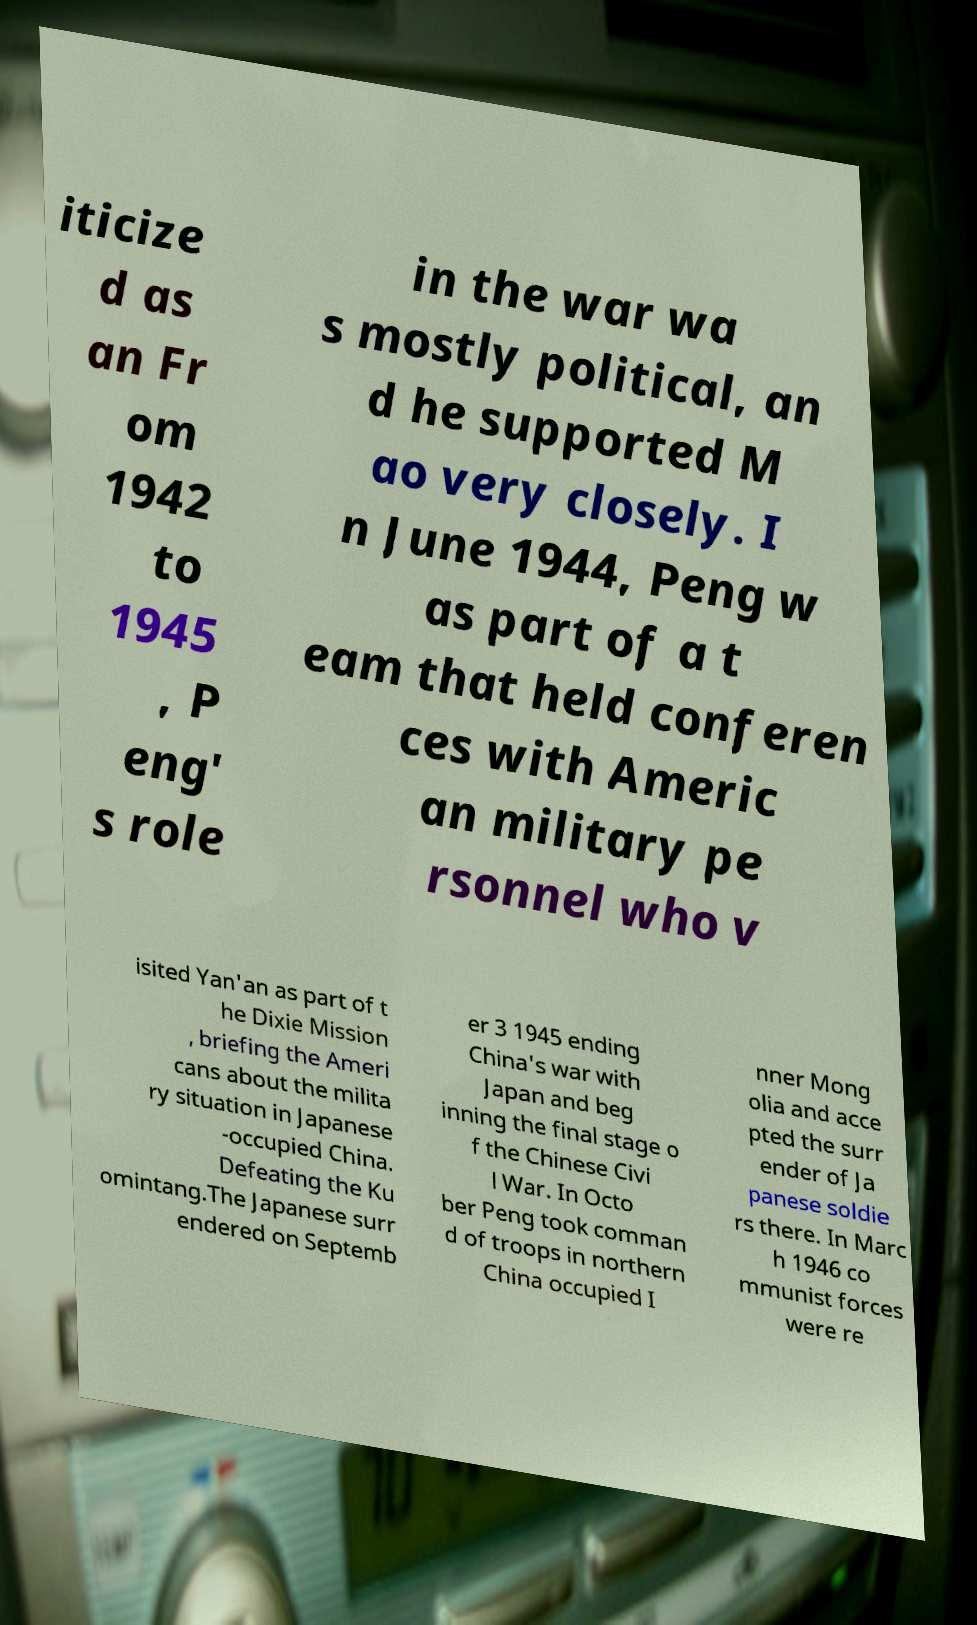I need the written content from this picture converted into text. Can you do that? iticize d as an Fr om 1942 to 1945 , P eng' s role in the war wa s mostly political, an d he supported M ao very closely. I n June 1944, Peng w as part of a t eam that held conferen ces with Americ an military pe rsonnel who v isited Yan'an as part of t he Dixie Mission , briefing the Ameri cans about the milita ry situation in Japanese -occupied China. Defeating the Ku omintang.The Japanese surr endered on Septemb er 3 1945 ending China's war with Japan and beg inning the final stage o f the Chinese Civi l War. In Octo ber Peng took comman d of troops in northern China occupied I nner Mong olia and acce pted the surr ender of Ja panese soldie rs there. In Marc h 1946 co mmunist forces were re 